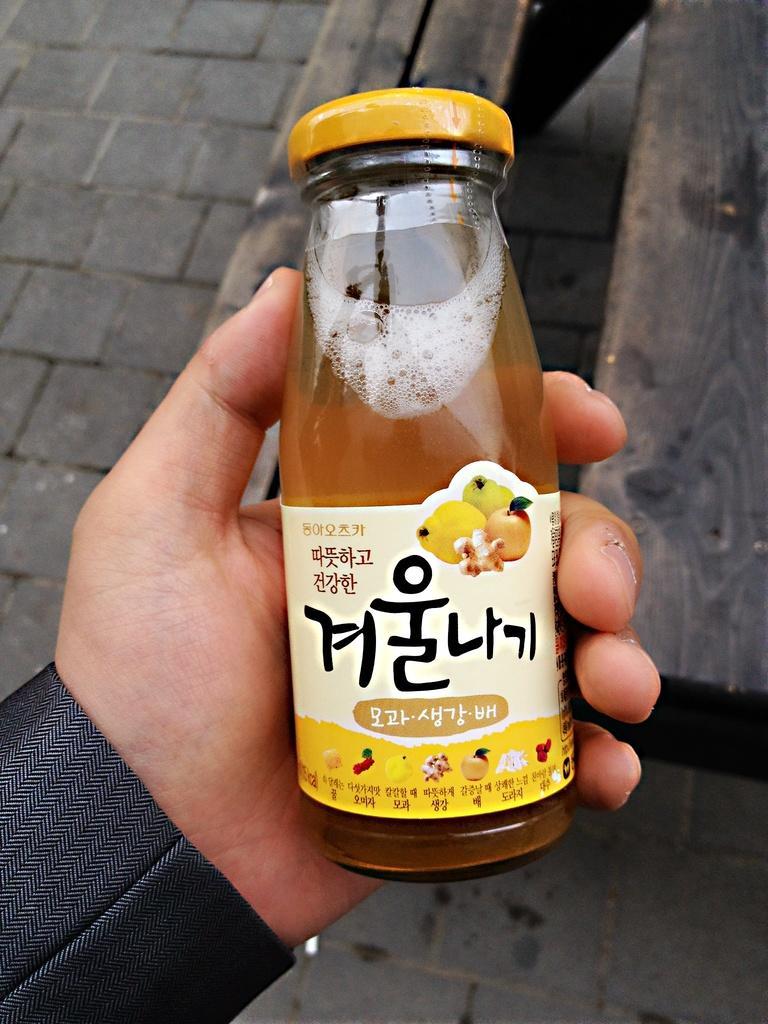Describe this image in one or two sentences. This is a small glass bottle with a yellow color closed lid. This looks like a juice bottle. This bottle is holded by a person in his hand. 